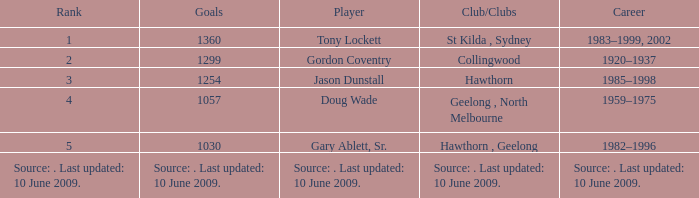In what club(s) does Tony Lockett play? St Kilda , Sydney. 